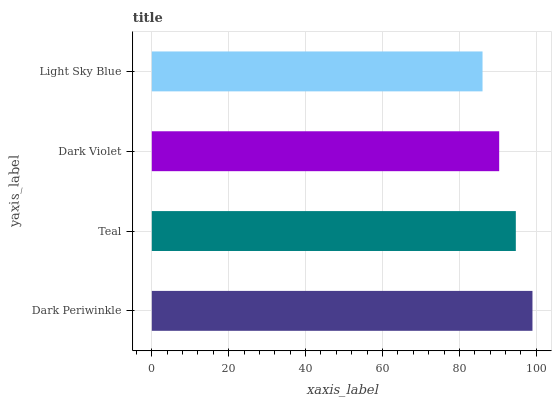Is Light Sky Blue the minimum?
Answer yes or no. Yes. Is Dark Periwinkle the maximum?
Answer yes or no. Yes. Is Teal the minimum?
Answer yes or no. No. Is Teal the maximum?
Answer yes or no. No. Is Dark Periwinkle greater than Teal?
Answer yes or no. Yes. Is Teal less than Dark Periwinkle?
Answer yes or no. Yes. Is Teal greater than Dark Periwinkle?
Answer yes or no. No. Is Dark Periwinkle less than Teal?
Answer yes or no. No. Is Teal the high median?
Answer yes or no. Yes. Is Dark Violet the low median?
Answer yes or no. Yes. Is Dark Violet the high median?
Answer yes or no. No. Is Light Sky Blue the low median?
Answer yes or no. No. 